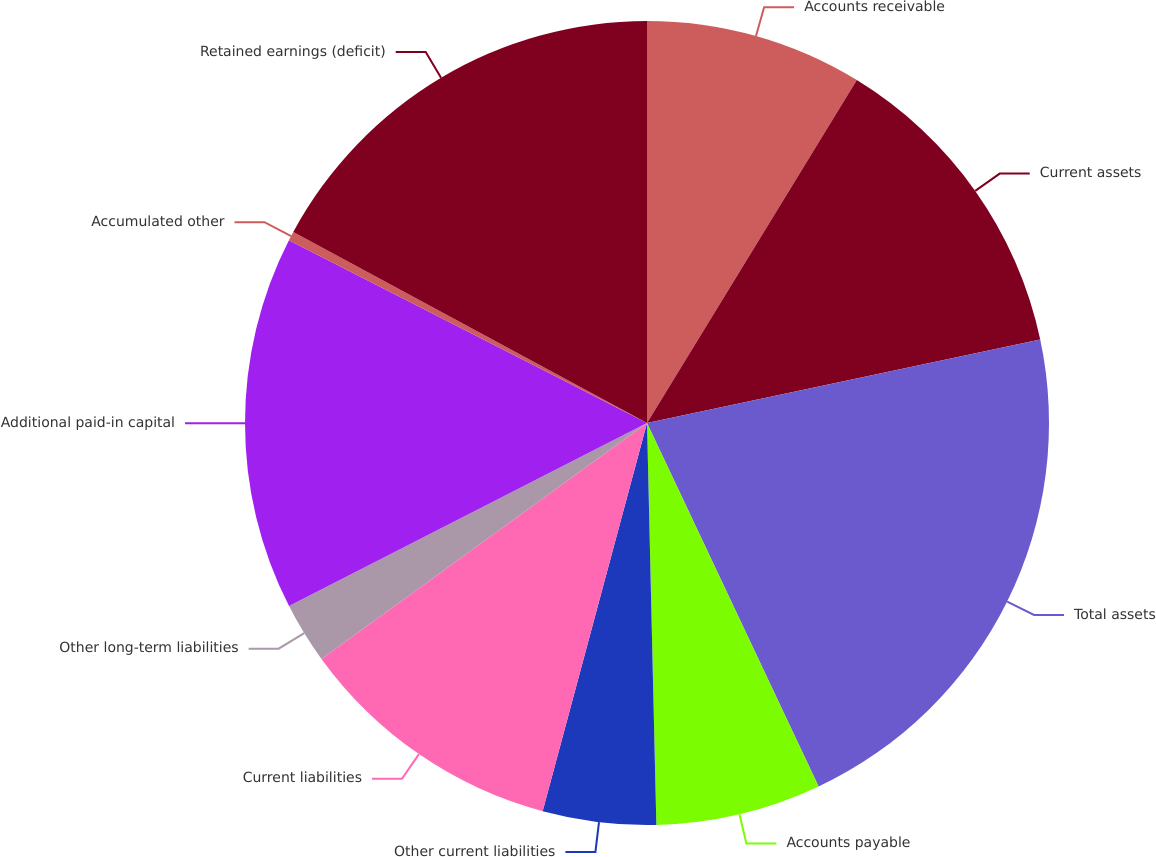Convert chart. <chart><loc_0><loc_0><loc_500><loc_500><pie_chart><fcel>Accounts receivable<fcel>Current assets<fcel>Total assets<fcel>Accounts payable<fcel>Other current liabilities<fcel>Current liabilities<fcel>Other long-term liabilities<fcel>Additional paid-in capital<fcel>Accumulated other<fcel>Retained earnings (deficit)<nl><fcel>8.74%<fcel>12.93%<fcel>21.31%<fcel>6.65%<fcel>4.55%<fcel>10.84%<fcel>2.46%<fcel>15.03%<fcel>0.37%<fcel>17.12%<nl></chart> 